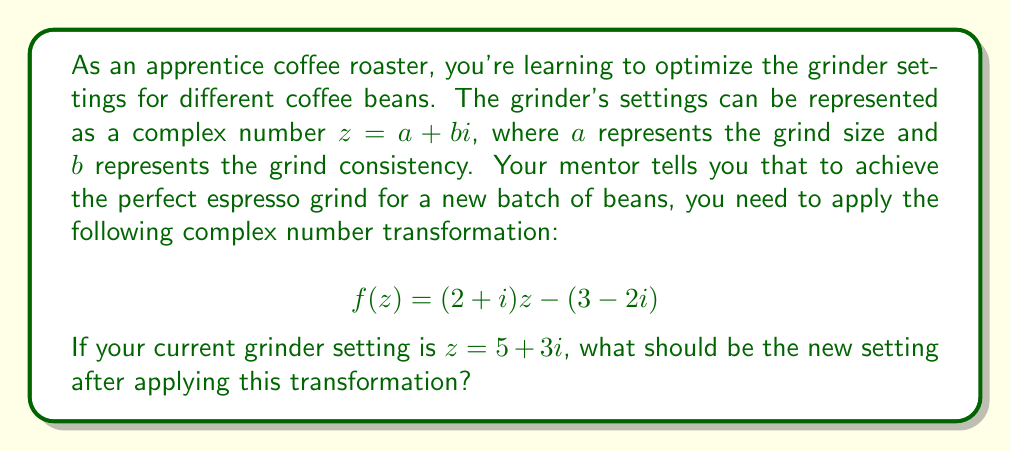Could you help me with this problem? Let's approach this step-by-step:

1) We start with the given transformation function:
   $$f(z) = (2+i)z - (3-2i)$$

2) We need to substitute $z = 5 + 3i$ into this function:
   $$f(5+3i) = (2+i)(5+3i) - (3-2i)$$

3) Let's first multiply $(2+i)(5+3i)$:
   $$(2+i)(5+3i) = 10 + 6i + 5i + 3i^2$$
   $$= 10 + 11i + 3(-1)$$ (since $i^2 = -1$)
   $$= 7 + 11i$$

4) Now our equation looks like this:
   $$f(5+3i) = (7 + 11i) - (3-2i)$$

5) Subtracting complex numbers means subtracting their real and imaginary parts separately:
   $$f(5+3i) = (7 - 3) + (11i - (-2i))$$
   $$= 4 + 13i$$

6) Therefore, the new grinder setting after applying the transformation is $4 + 13i$.

7) In the context of our problem, this means the new grind size should be 4 (units) and the new grind consistency should be 13 (units).
Answer: $4 + 13i$ 